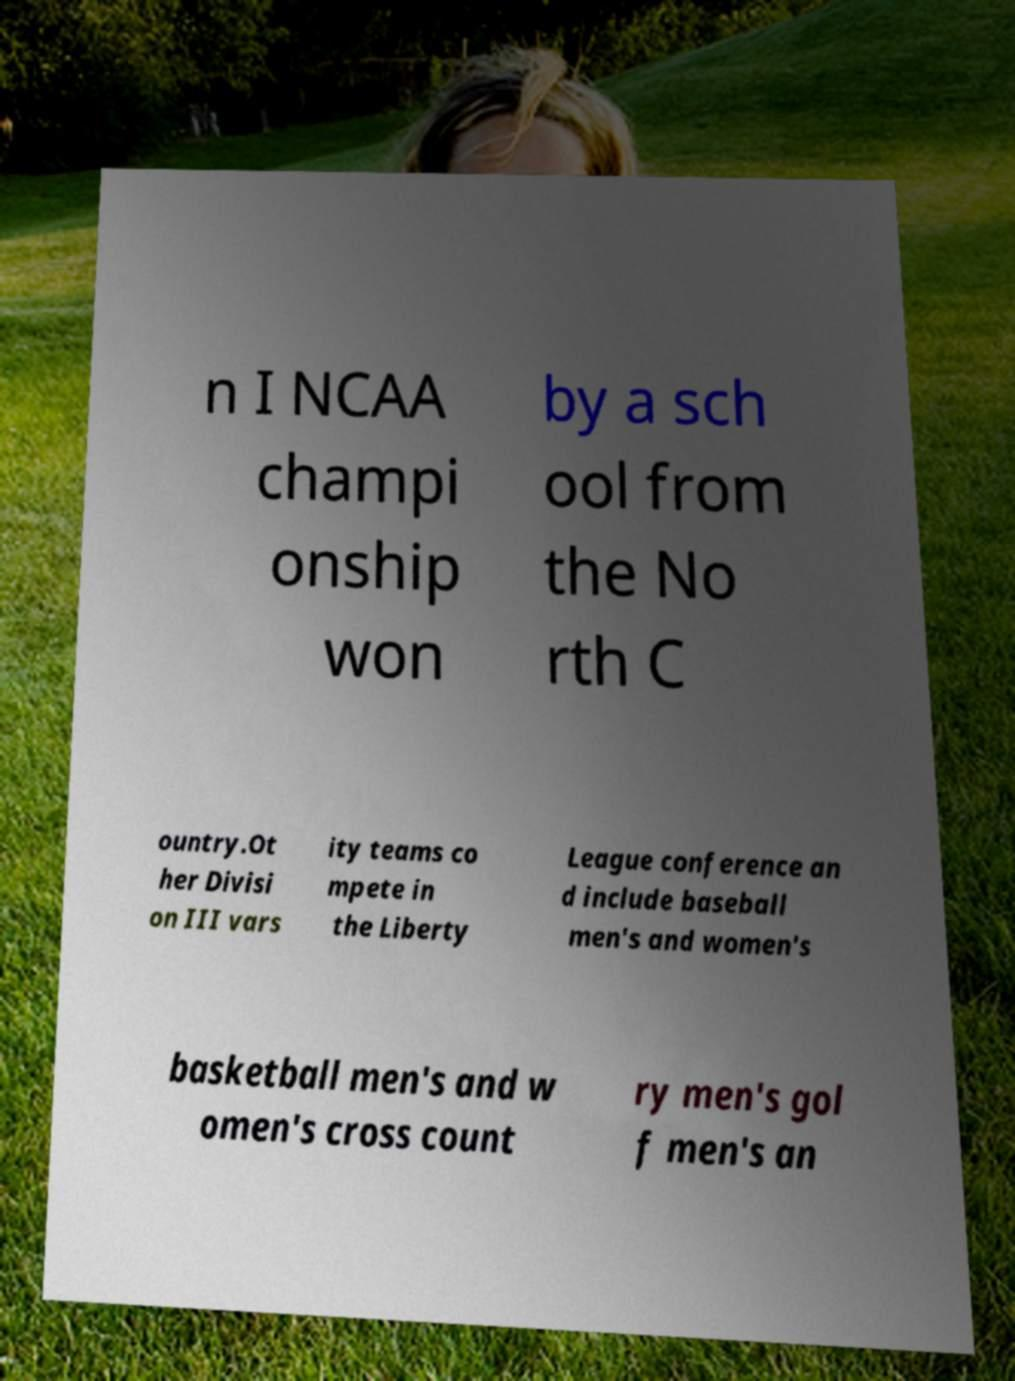I need the written content from this picture converted into text. Can you do that? n I NCAA champi onship won by a sch ool from the No rth C ountry.Ot her Divisi on III vars ity teams co mpete in the Liberty League conference an d include baseball men's and women's basketball men's and w omen's cross count ry men's gol f men's an 